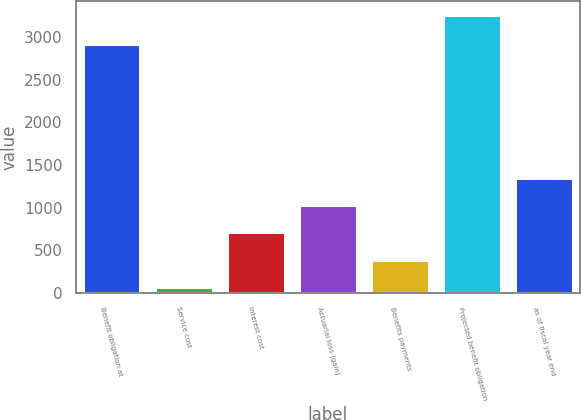Convert chart to OTSL. <chart><loc_0><loc_0><loc_500><loc_500><bar_chart><fcel>Benefit obligation at<fcel>Service cost<fcel>Interest cost<fcel>Actuarial loss (gain)<fcel>Benefits payments<fcel>Projected benefit obligation<fcel>as of fiscal year end<nl><fcel>2916.4<fcel>73.1<fcel>709.98<fcel>1028.42<fcel>391.54<fcel>3257.5<fcel>1346.86<nl></chart> 